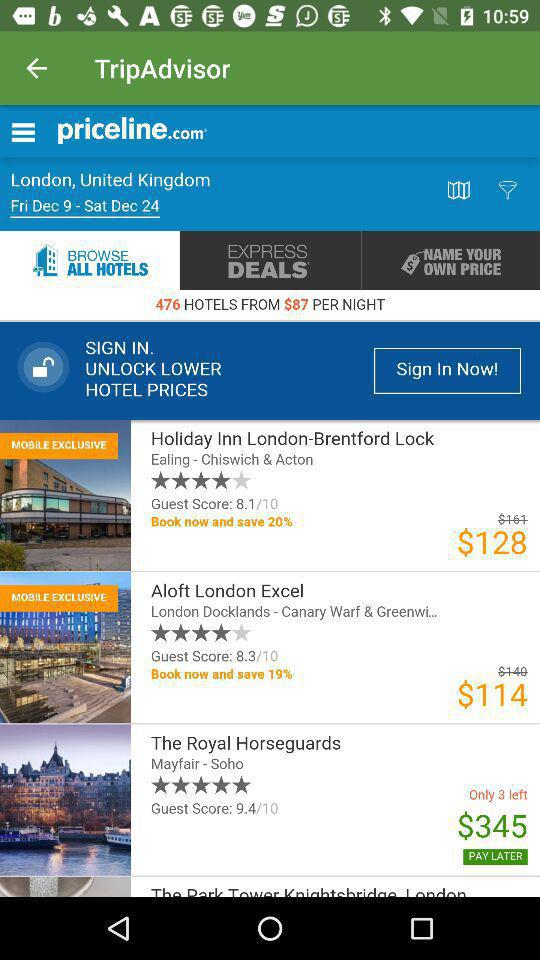How many rooms are left in "The Royal Horseguards"? The number of rooms left in "The Royal Horseguards" is 3. 